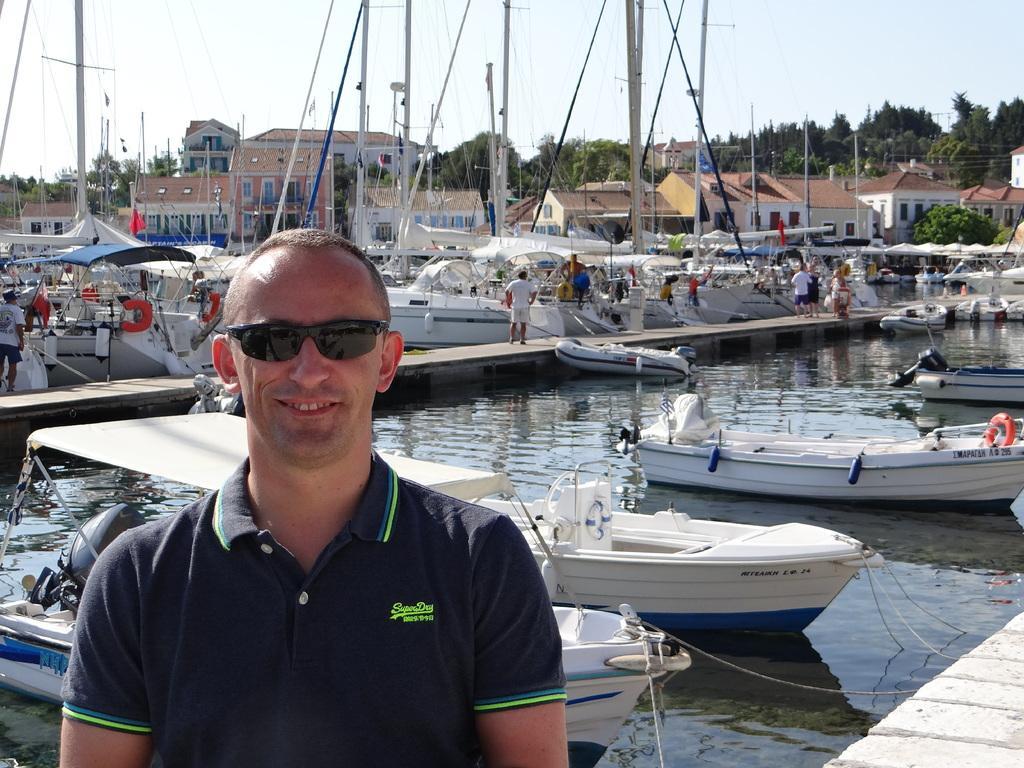Describe this image in one or two sentences. In the foreground of the image there is a person wearing T-shirt and sunglasses. In the background of the image there are boats, water, people, houses, trees and sky. 